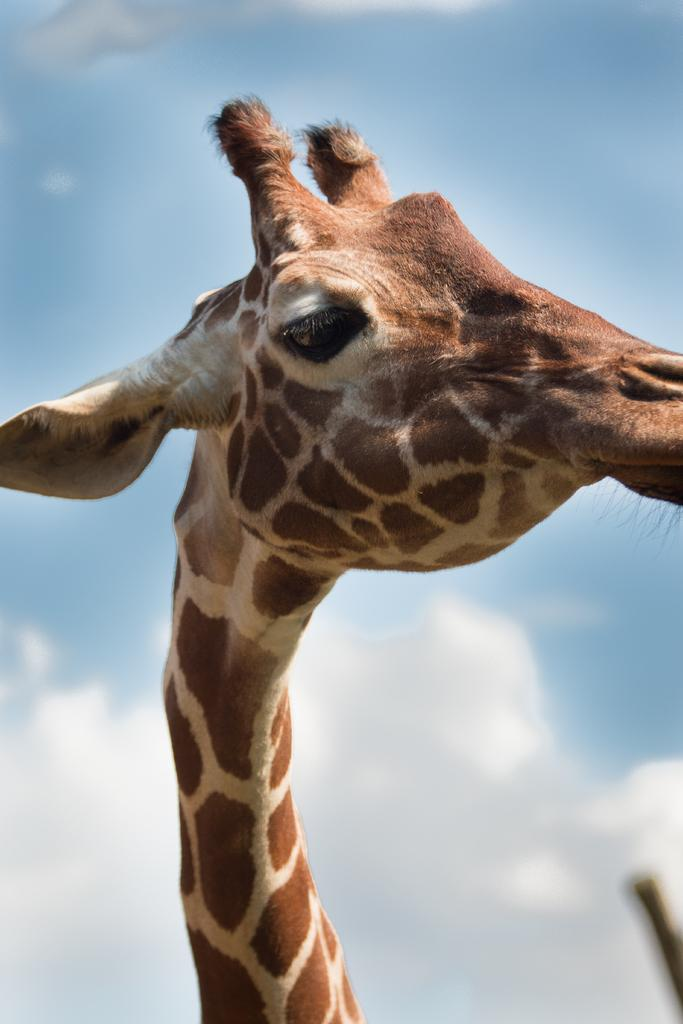Where was the image taken? The image was taken outdoors. What can be seen in the background of the image? There is a sky with clouds in the background of the image. What is the main subject of the image? There is a giraffe in the middle of the image. How many snakes are wrapped around the giraffe in the image? There are no snakes present in the image; it features a giraffe standing alone. What type of yarn is being used to create the clouds in the image? The image does not depict yarn being used to create the clouds; the clouds are a natural part of the sky. 